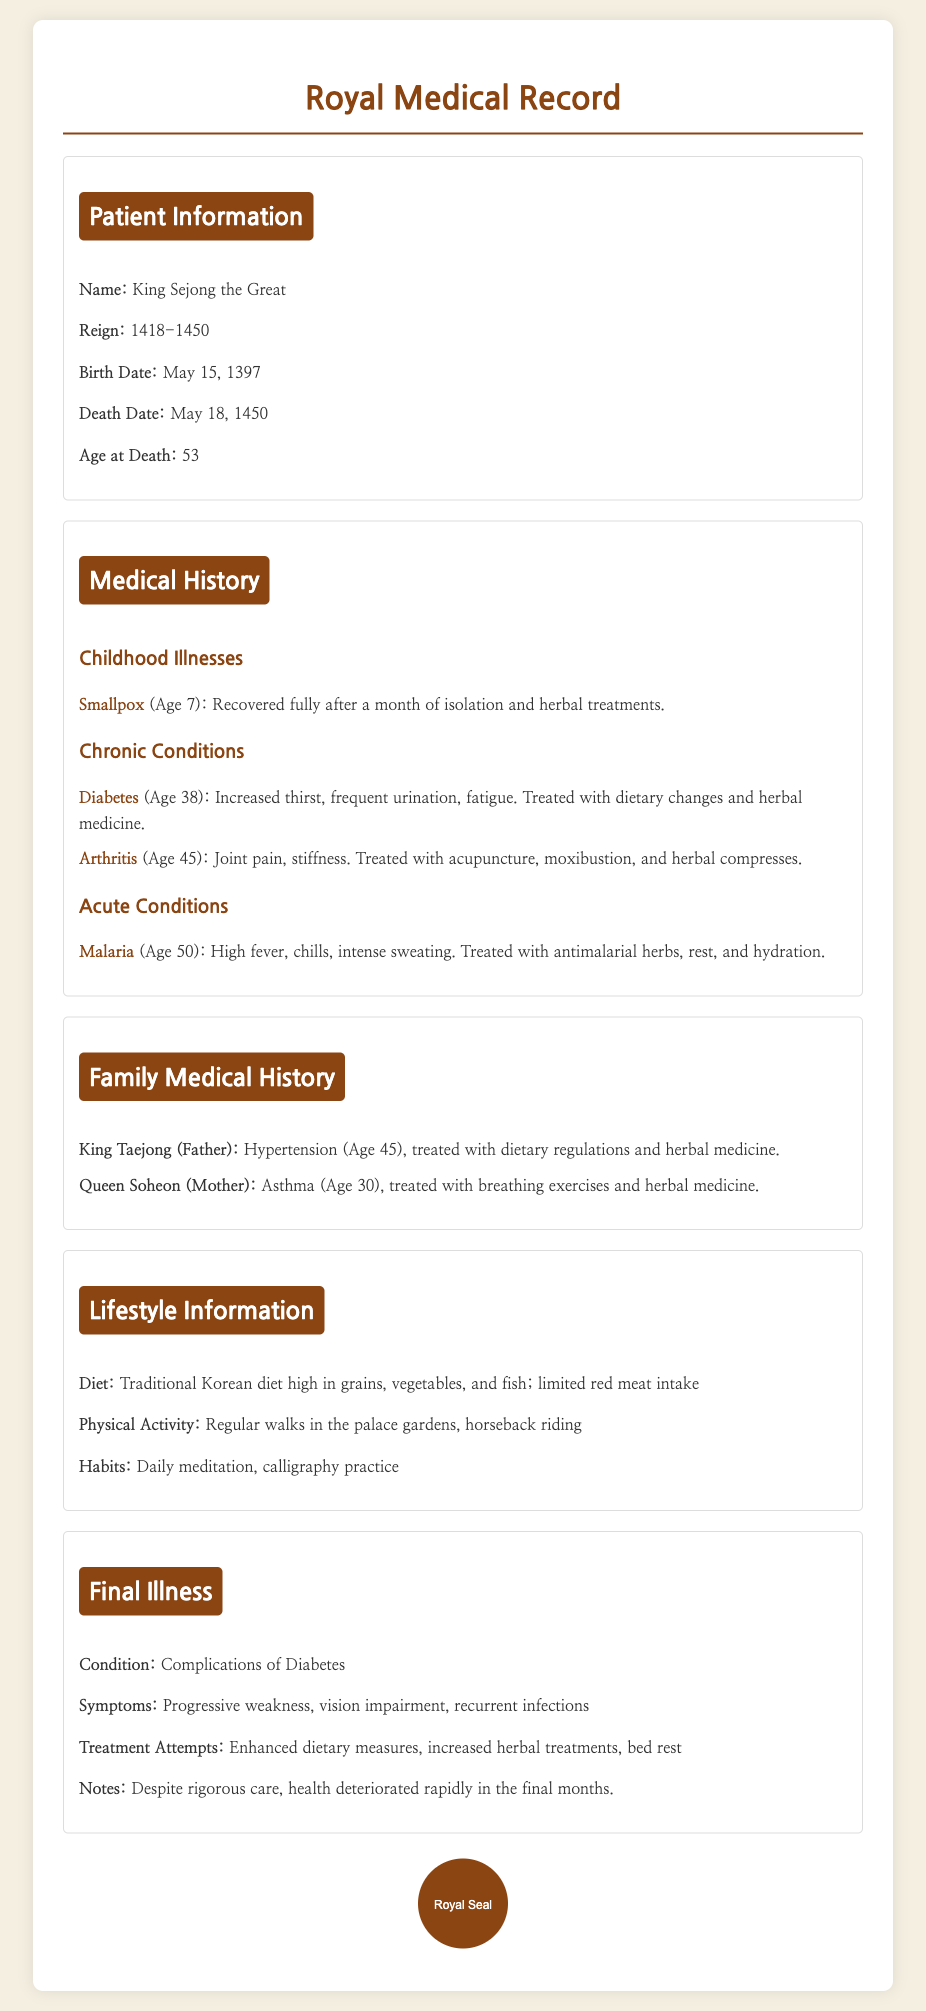What is the full name of the patient? The patient's full name provided in the document is "King Sejong the Great."
Answer: King Sejong the Great During which years did King Sejong reign? The reign years of King Sejong are explicitly listed in the document as 1418-1450.
Answer: 1418-1450 How old was King Sejong when he died? The document states that King Sejong was 53 at the time of his death.
Answer: 53 What illness did King Sejong recover from at age 7? According to the medical history, King Sejong had smallpox at age 7.
Answer: Smallpox What were King Sejong's chronic conditions? The document notes that King Sejong had diabetes and arthritis as chronic conditions.
Answer: Diabetes, Arthritis What was the primary cause of King Sejong's final illness? The document indicates that the final illness was due to complications of diabetes.
Answer: Complications of Diabetes What treatment did King Sejong's father have for his hypertension? The treatment for King Taejong's hypertension was dietary regulations and herbal medicine.
Answer: Dietary regulations and herbal medicine What type of physical activity did King Sejong engage in? The lifestyle information mentions that King Sejong regularly took walks in the palace gardens and rode horseback.
Answer: Regular walks in the palace gardens, horseback riding What is noted about King Sejong's health deterioration in his final months? The document notes a rapid health deterioration despite rigorous care in the final months.
Answer: Rapid health deterioration 